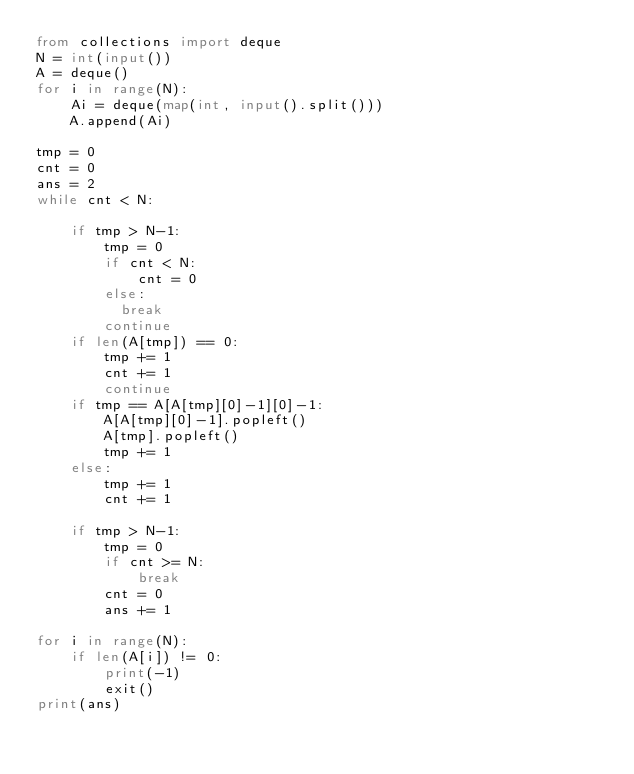<code> <loc_0><loc_0><loc_500><loc_500><_Python_>from collections import deque
N = int(input())
A = deque()
for i in range(N):
    Ai = deque(map(int, input().split()))
    A.append(Ai)

tmp = 0
cnt = 0
ans = 2
while cnt < N:

    if tmp > N-1:
        tmp = 0
        if cnt < N:
            cnt = 0
        else:
          break
        continue
    if len(A[tmp]) == 0:
        tmp += 1
        cnt += 1
        continue
    if tmp == A[A[tmp][0]-1][0]-1:
        A[A[tmp][0]-1].popleft()
        A[tmp].popleft()
        tmp += 1
    else:
        tmp += 1
        cnt += 1
    
    if tmp > N-1:
        tmp = 0
        if cnt >= N:
            break
        cnt = 0
        ans += 1

for i in range(N):
    if len(A[i]) != 0:
        print(-1)
        exit()
print(ans)</code> 